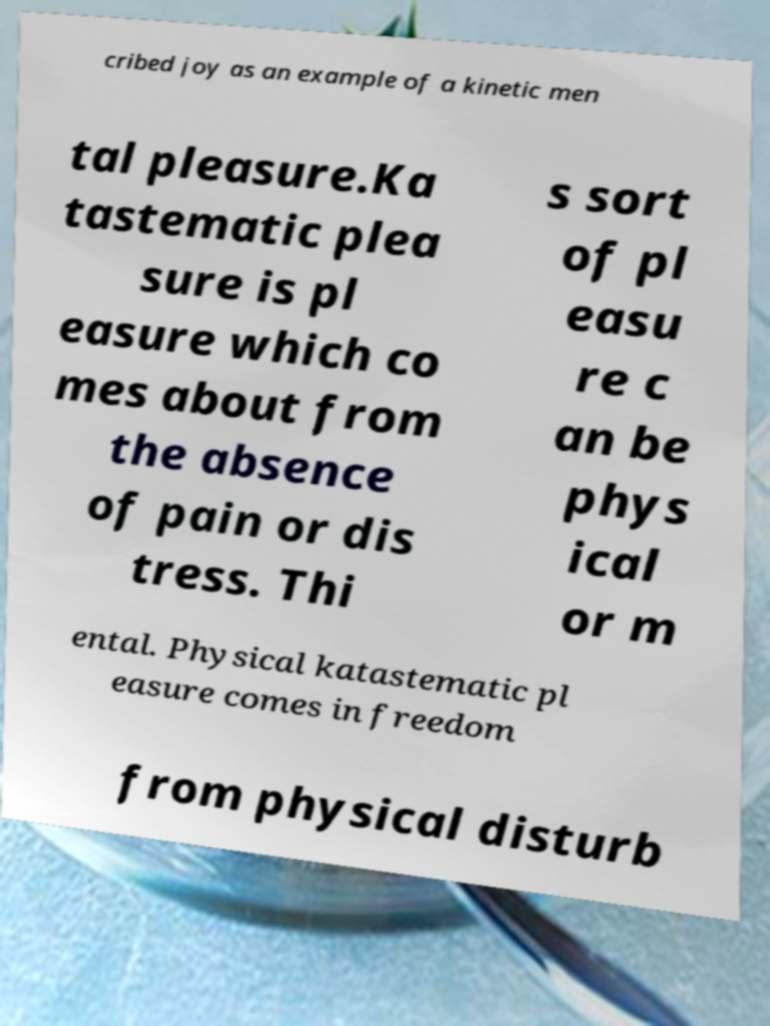Could you assist in decoding the text presented in this image and type it out clearly? cribed joy as an example of a kinetic men tal pleasure.Ka tastematic plea sure is pl easure which co mes about from the absence of pain or dis tress. Thi s sort of pl easu re c an be phys ical or m ental. Physical katastematic pl easure comes in freedom from physical disturb 